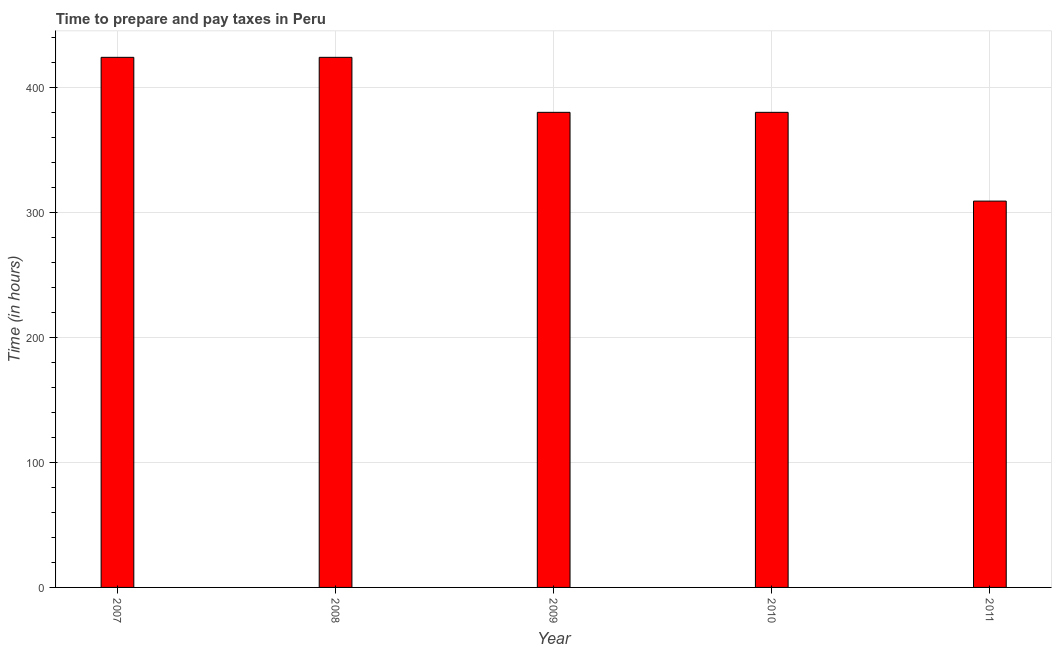Does the graph contain any zero values?
Ensure brevity in your answer.  No. What is the title of the graph?
Your response must be concise. Time to prepare and pay taxes in Peru. What is the label or title of the X-axis?
Make the answer very short. Year. What is the label or title of the Y-axis?
Offer a terse response. Time (in hours). What is the time to prepare and pay taxes in 2009?
Provide a short and direct response. 380. Across all years, what is the maximum time to prepare and pay taxes?
Offer a very short reply. 424. Across all years, what is the minimum time to prepare and pay taxes?
Keep it short and to the point. 309. In which year was the time to prepare and pay taxes maximum?
Offer a terse response. 2007. In which year was the time to prepare and pay taxes minimum?
Provide a succinct answer. 2011. What is the sum of the time to prepare and pay taxes?
Your response must be concise. 1917. What is the difference between the time to prepare and pay taxes in 2007 and 2010?
Give a very brief answer. 44. What is the average time to prepare and pay taxes per year?
Ensure brevity in your answer.  383. What is the median time to prepare and pay taxes?
Provide a succinct answer. 380. In how many years, is the time to prepare and pay taxes greater than 220 hours?
Your answer should be very brief. 5. Do a majority of the years between 2011 and 2007 (inclusive) have time to prepare and pay taxes greater than 80 hours?
Offer a very short reply. Yes. What is the ratio of the time to prepare and pay taxes in 2007 to that in 2009?
Give a very brief answer. 1.12. Is the time to prepare and pay taxes in 2008 less than that in 2011?
Offer a terse response. No. Is the difference between the time to prepare and pay taxes in 2007 and 2010 greater than the difference between any two years?
Your response must be concise. No. What is the difference between the highest and the second highest time to prepare and pay taxes?
Provide a succinct answer. 0. Is the sum of the time to prepare and pay taxes in 2007 and 2009 greater than the maximum time to prepare and pay taxes across all years?
Offer a terse response. Yes. What is the difference between the highest and the lowest time to prepare and pay taxes?
Offer a terse response. 115. In how many years, is the time to prepare and pay taxes greater than the average time to prepare and pay taxes taken over all years?
Offer a very short reply. 2. How many bars are there?
Your answer should be very brief. 5. How many years are there in the graph?
Your response must be concise. 5. What is the difference between two consecutive major ticks on the Y-axis?
Ensure brevity in your answer.  100. Are the values on the major ticks of Y-axis written in scientific E-notation?
Provide a short and direct response. No. What is the Time (in hours) of 2007?
Offer a very short reply. 424. What is the Time (in hours) of 2008?
Offer a terse response. 424. What is the Time (in hours) of 2009?
Give a very brief answer. 380. What is the Time (in hours) of 2010?
Your response must be concise. 380. What is the Time (in hours) in 2011?
Make the answer very short. 309. What is the difference between the Time (in hours) in 2007 and 2009?
Make the answer very short. 44. What is the difference between the Time (in hours) in 2007 and 2010?
Give a very brief answer. 44. What is the difference between the Time (in hours) in 2007 and 2011?
Provide a short and direct response. 115. What is the difference between the Time (in hours) in 2008 and 2010?
Offer a very short reply. 44. What is the difference between the Time (in hours) in 2008 and 2011?
Ensure brevity in your answer.  115. What is the difference between the Time (in hours) in 2009 and 2010?
Your answer should be very brief. 0. What is the difference between the Time (in hours) in 2010 and 2011?
Give a very brief answer. 71. What is the ratio of the Time (in hours) in 2007 to that in 2009?
Your response must be concise. 1.12. What is the ratio of the Time (in hours) in 2007 to that in 2010?
Your answer should be compact. 1.12. What is the ratio of the Time (in hours) in 2007 to that in 2011?
Provide a succinct answer. 1.37. What is the ratio of the Time (in hours) in 2008 to that in 2009?
Ensure brevity in your answer.  1.12. What is the ratio of the Time (in hours) in 2008 to that in 2010?
Give a very brief answer. 1.12. What is the ratio of the Time (in hours) in 2008 to that in 2011?
Offer a terse response. 1.37. What is the ratio of the Time (in hours) in 2009 to that in 2011?
Your response must be concise. 1.23. What is the ratio of the Time (in hours) in 2010 to that in 2011?
Give a very brief answer. 1.23. 